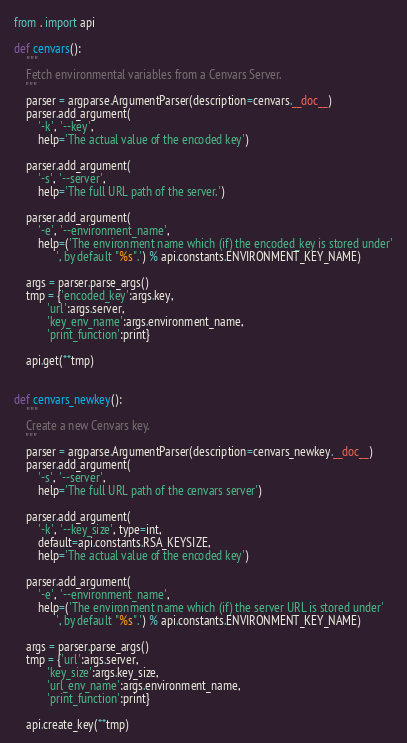<code> <loc_0><loc_0><loc_500><loc_500><_Python_>from . import api

def cenvars():
    """
    Fetch environmental variables from a Cenvars Server.
    """
    parser = argparse.ArgumentParser(description=cenvars.__doc__)
    parser.add_argument(
        '-k', '--key',
        help='The actual value of the encoded key')

    parser.add_argument(
        '-s', '--server',
        help='The full URL path of the server.')

    parser.add_argument(
        '-e', '--environment_name',
        help=('The environment name which (if) the encoded_key is stored under'
              ', by default "%s".') % api.constants.ENVIRONMENT_KEY_NAME)

    args = parser.parse_args()
    tmp = {'encoded_key':args.key,
           'url':args.server,
           'key_env_name':args.environment_name,
           'print_function':print}

    api.get(**tmp)


def cenvars_newkey():
    """
    Create a new Cenvars key.
    """
    parser = argparse.ArgumentParser(description=cenvars_newkey.__doc__)
    parser.add_argument(
        '-s', '--server',
        help='The full URL path of the cenvars server')

    parser.add_argument(
        '-k', '--key_size', type=int,
        default=api.constants.RSA_KEYSIZE,
        help='The actual value of the encoded key')

    parser.add_argument(
        '-e', '--environment_name',
        help=('The environment name which (if) the server URL is stored under'
              ', by default "%s".') % api.constants.ENVIRONMENT_KEY_NAME)

    args = parser.parse_args()
    tmp = {'url':args.server,
           'key_size':args.key_size,
           'url_env_name':args.environment_name,
           'print_function':print}

    api.create_key(**tmp)
</code> 